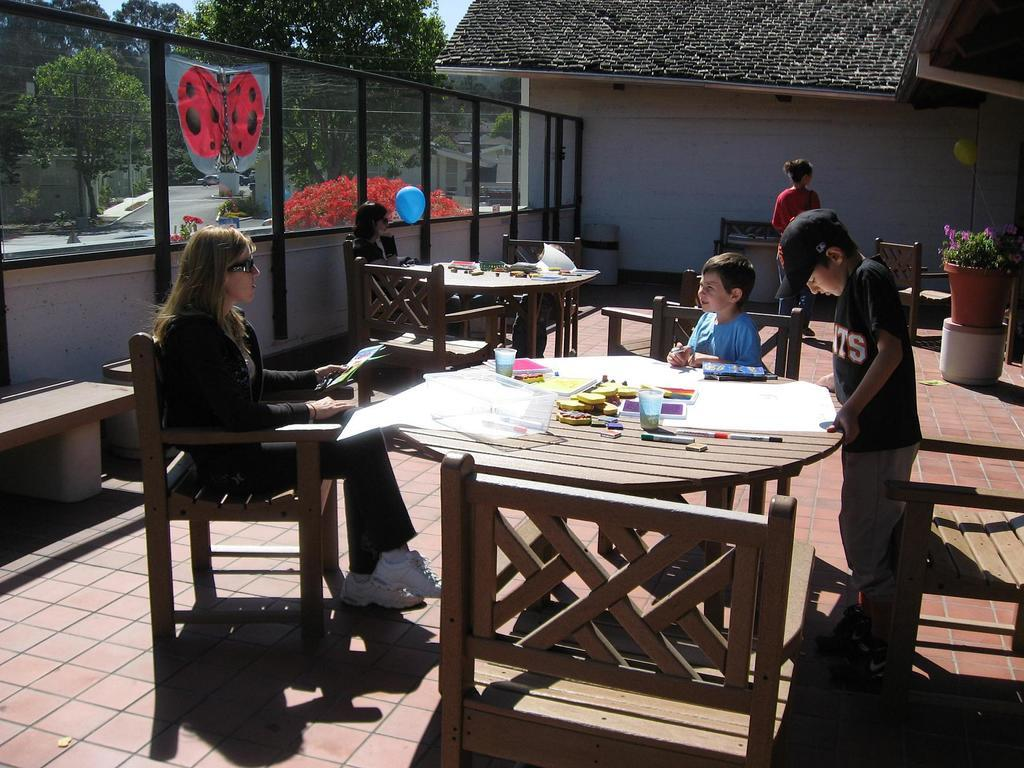Who is present in the image? There is a woman, a boy seated on a chair, and another boy standing in the image. What is the standing boy doing? The standing boy is looking at a paper. What is the woman in the image doing? The woman is walking in the image. How many boys are present in the image? There are two boys present in the image. What type of leather is the boy smashing with a crown in the image? There is no leather, smashing, or crown present in the image. 